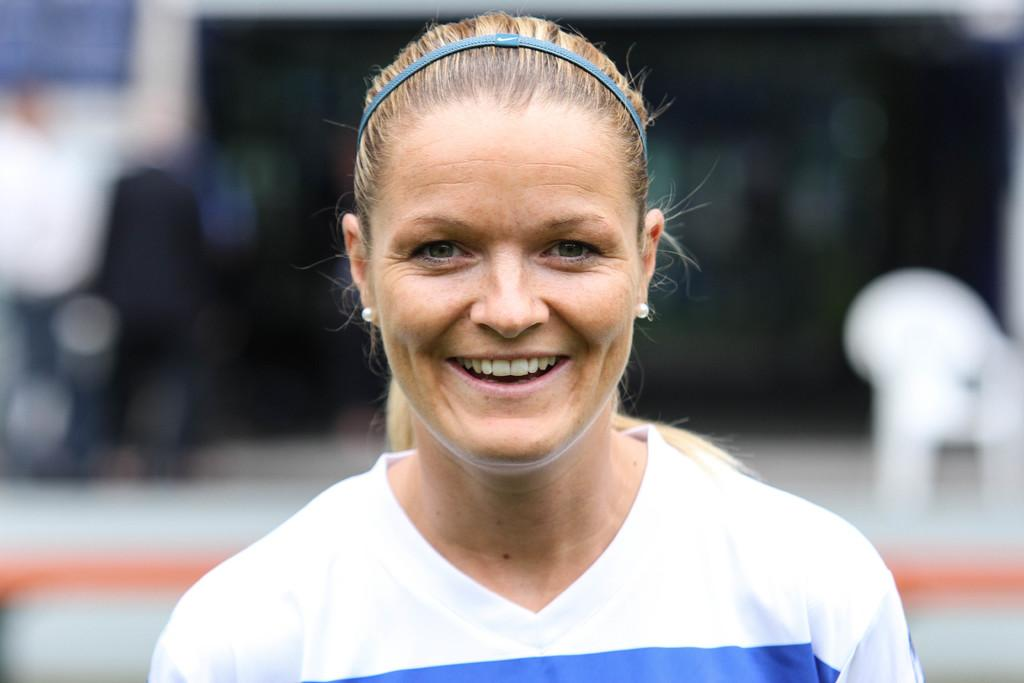Who is the main subject in the image? There is a woman in the image. What is the woman wearing? The woman is wearing a white dress. What expression does the woman have? The woman is smiling. How would you describe the quality of the image? The image is blurry in the background. What type of basketball shoes is the woman wearing in the image? There is no mention of basketball shoes or any sports-related items in the image. The woman is wearing a white dress, and there is no indication of footwear. 